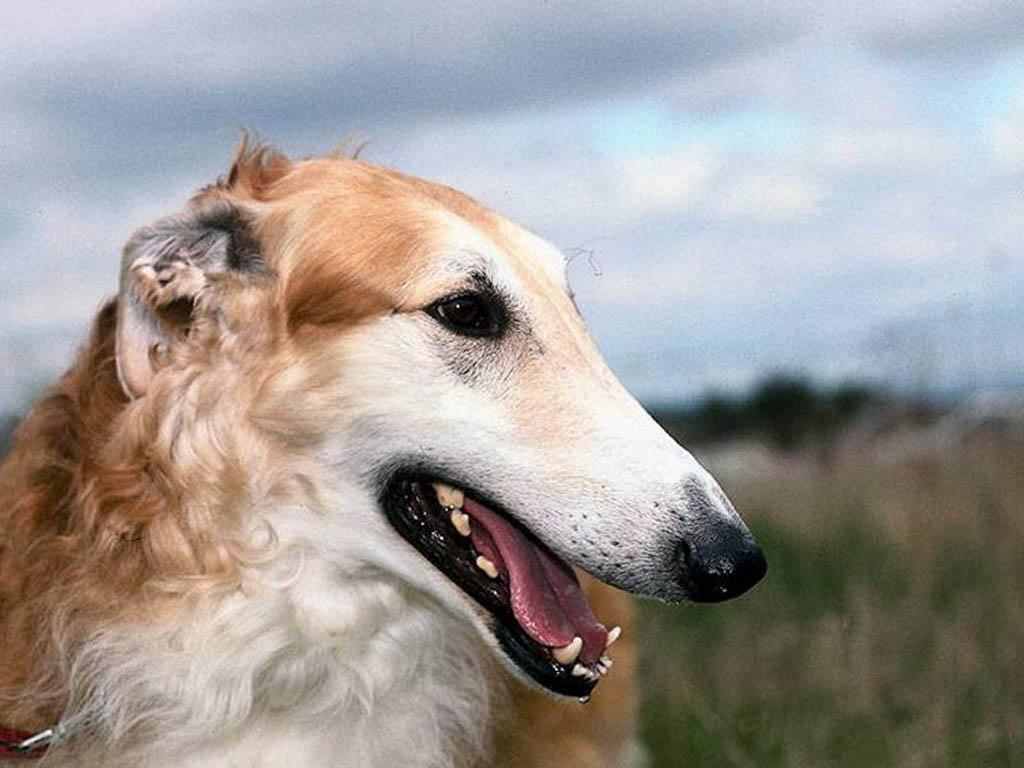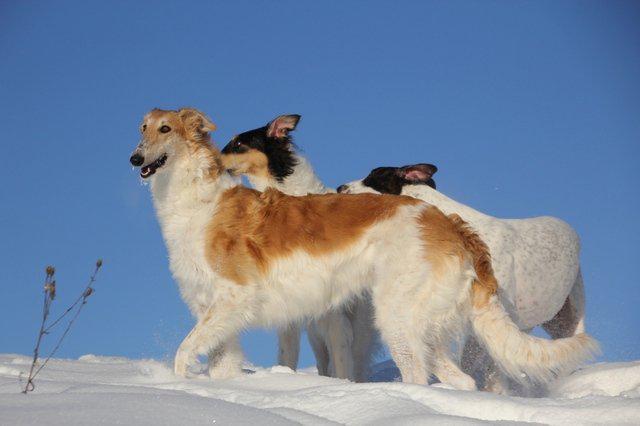The first image is the image on the left, the second image is the image on the right. Assess this claim about the two images: "One image shows a trio of dogs, with two reclining next to a standing dog.". Correct or not? Answer yes or no. No. The first image is the image on the left, the second image is the image on the right. Examine the images to the left and right. Is the description "One of the two dogs in the image on the left is standing while the other is lying down." accurate? Answer yes or no. No. 